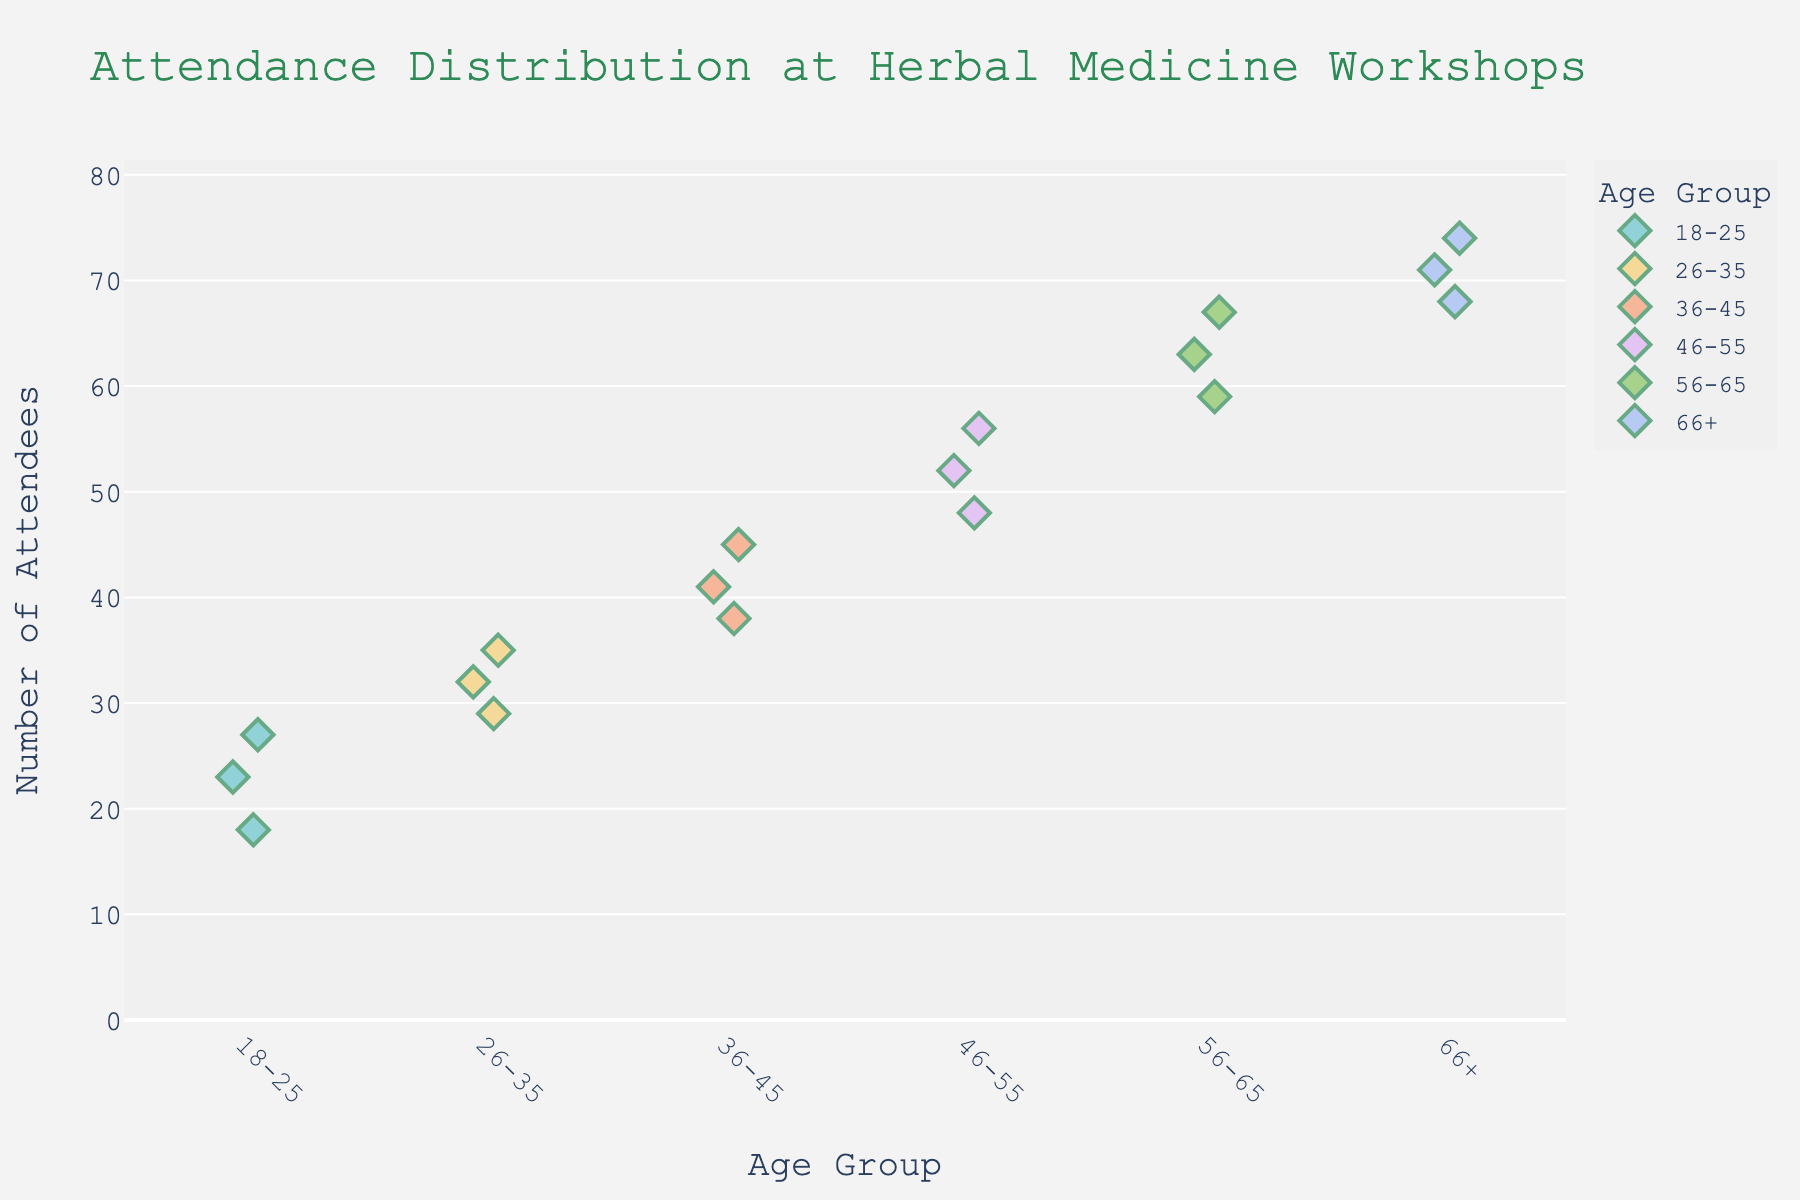What's the title of the plot? The title is displayed at the top of the plot.
Answer: Attendance Distribution at Herbal Medicine Workshops Which age group has the highest attendance? By looking at the topmost point on the y-axis for each age group, we see that the 66+ group has the highest attendance value of 74.
Answer: 66+ What is the attendance range for the 36-45 age group? The smallest attendance value for the 36-45 group is 38, and the largest is 45. The range is 45 - 38 = 7.
Answer: 7 How does the average attendance of the 26-35 group compare to the 56-65 group? The attendance values for the 26-35 group are 32, 29, and 35. The sum is 32 + 29 + 35 = 96 and the average is 96 / 3 = 32. The attendance values for the 56-65 group are 63, 59, and 67. The sum is 63 + 59 + 67 = 189 and the average is 189 / 3 = 63. 32 is less than 63.
Answer: 32 is less than 63 What's the median attendance value for the 18-25 age group? The attendance values for the 18-25 group are 23, 18, and 27. When sorted, they are 18, 23, 27. The median value, which is the middle one, is 23.
Answer: 23 How many data points are there for the 46-55 age group? By counting the number of attendance values associated with the 46-55 age group, we see there are 3 data points: 52, 48, and 56.
Answer: 3 What is the maximum attendance observed in the figure? Looking at the highest point on the y-axis across all age groups, the maximum attendance is 74.
Answer: 74 Are there any age groups with identical number of data points? Each age group has 3 data points plotted. Count the attendance values for each group to verify this: 18-25 (3), 26-35 (3), 36-45 (3), 46-55 (3), 56-65 (3), and 66+ (3).
Answer: Yes What age group has the smallest average attendance? To find this, calculate the average for each group and compare them. The 18-25 group has attendance values of 23, 18, and 27. Their sum is 23 + 18 + 27 = 68, and the average is 68 / 3 ≈ 22.67. This is the smallest compared to other groups' averages.
Answer: 18-25 How much larger is the highest attendance compared to the lowest attendance in the entire dataset? The highest attendance value is 74 (66+ group) and the lowest is 18 (18-25 group). Calculate the difference: 74 - 18 = 56.
Answer: 56 